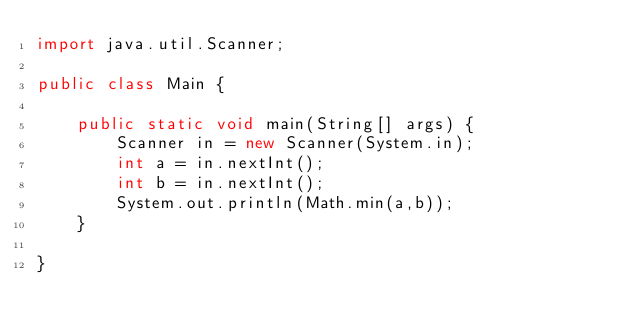<code> <loc_0><loc_0><loc_500><loc_500><_Java_>import java.util.Scanner;

public class Main {

    public static void main(String[] args) {
        Scanner in = new Scanner(System.in);
        int a = in.nextInt();
        int b = in.nextInt();
        System.out.println(Math.min(a,b));
    }

}</code> 